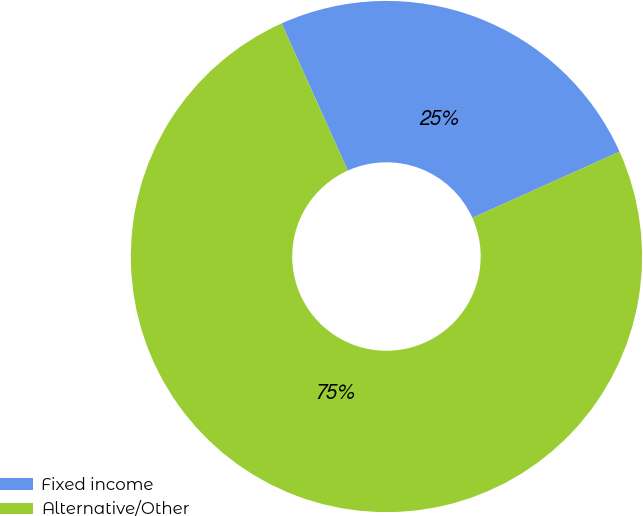<chart> <loc_0><loc_0><loc_500><loc_500><pie_chart><fcel>Fixed income<fcel>Alternative/Other<nl><fcel>25.0%<fcel>75.0%<nl></chart> 